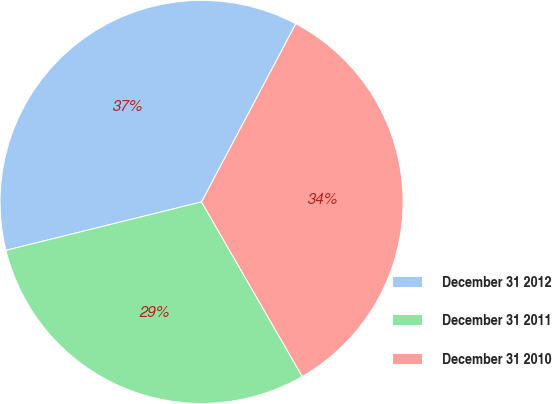<chart> <loc_0><loc_0><loc_500><loc_500><pie_chart><fcel>December 31 2012<fcel>December 31 2011<fcel>December 31 2010<nl><fcel>36.61%<fcel>29.47%<fcel>33.92%<nl></chart> 